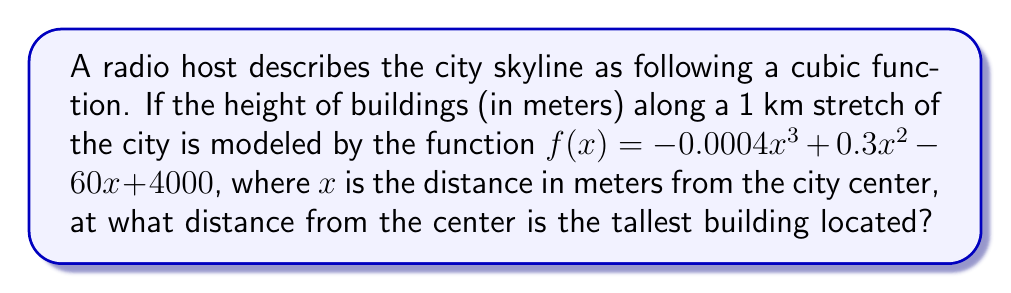Give your solution to this math problem. To find the location of the tallest building, we need to determine the maximum point of the cubic function. This can be done by following these steps:

1) First, we find the derivative of the function:
   $$f'(x) = -0.0012x^2 + 0.6x - 60$$

2) To find the maximum point, we set the derivative to zero and solve for x:
   $$-0.0012x^2 + 0.6x - 60 = 0$$

3) This is a quadratic equation. We can solve it using the quadratic formula:
   $$x = \frac{-b \pm \sqrt{b^2 - 4ac}}{2a}$$
   where $a = -0.0012$, $b = 0.6$, and $c = -60$

4) Substituting these values:
   $$x = \frac{-0.6 \pm \sqrt{0.6^2 - 4(-0.0012)(-60)}}{2(-0.0012)}$$

5) Simplifying:
   $$x = \frac{-0.6 \pm \sqrt{0.36 - 0.288}}{-0.0024} = \frac{-0.6 \pm \sqrt{0.072}}{-0.0024}$$

6) This gives us two solutions:
   $$x_1 \approx 333.33 \text{ meters}$$
   $$x_2 \approx 166.67 \text{ meters}$$

7) To determine which of these is the maximum (rather than the minimum), we can check the second derivative:
   $$f''(x) = -0.0024x + 0.6$$

8) At $x = 333.33$, $f''(333.33) < 0$, indicating this is the maximum point.

Therefore, the tallest building is located approximately 333.33 meters from the city center.
Answer: 333.33 meters 